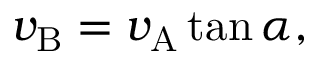Convert formula to latex. <formula><loc_0><loc_0><loc_500><loc_500>v _ { B } = v _ { A } \tan \alpha ,</formula> 